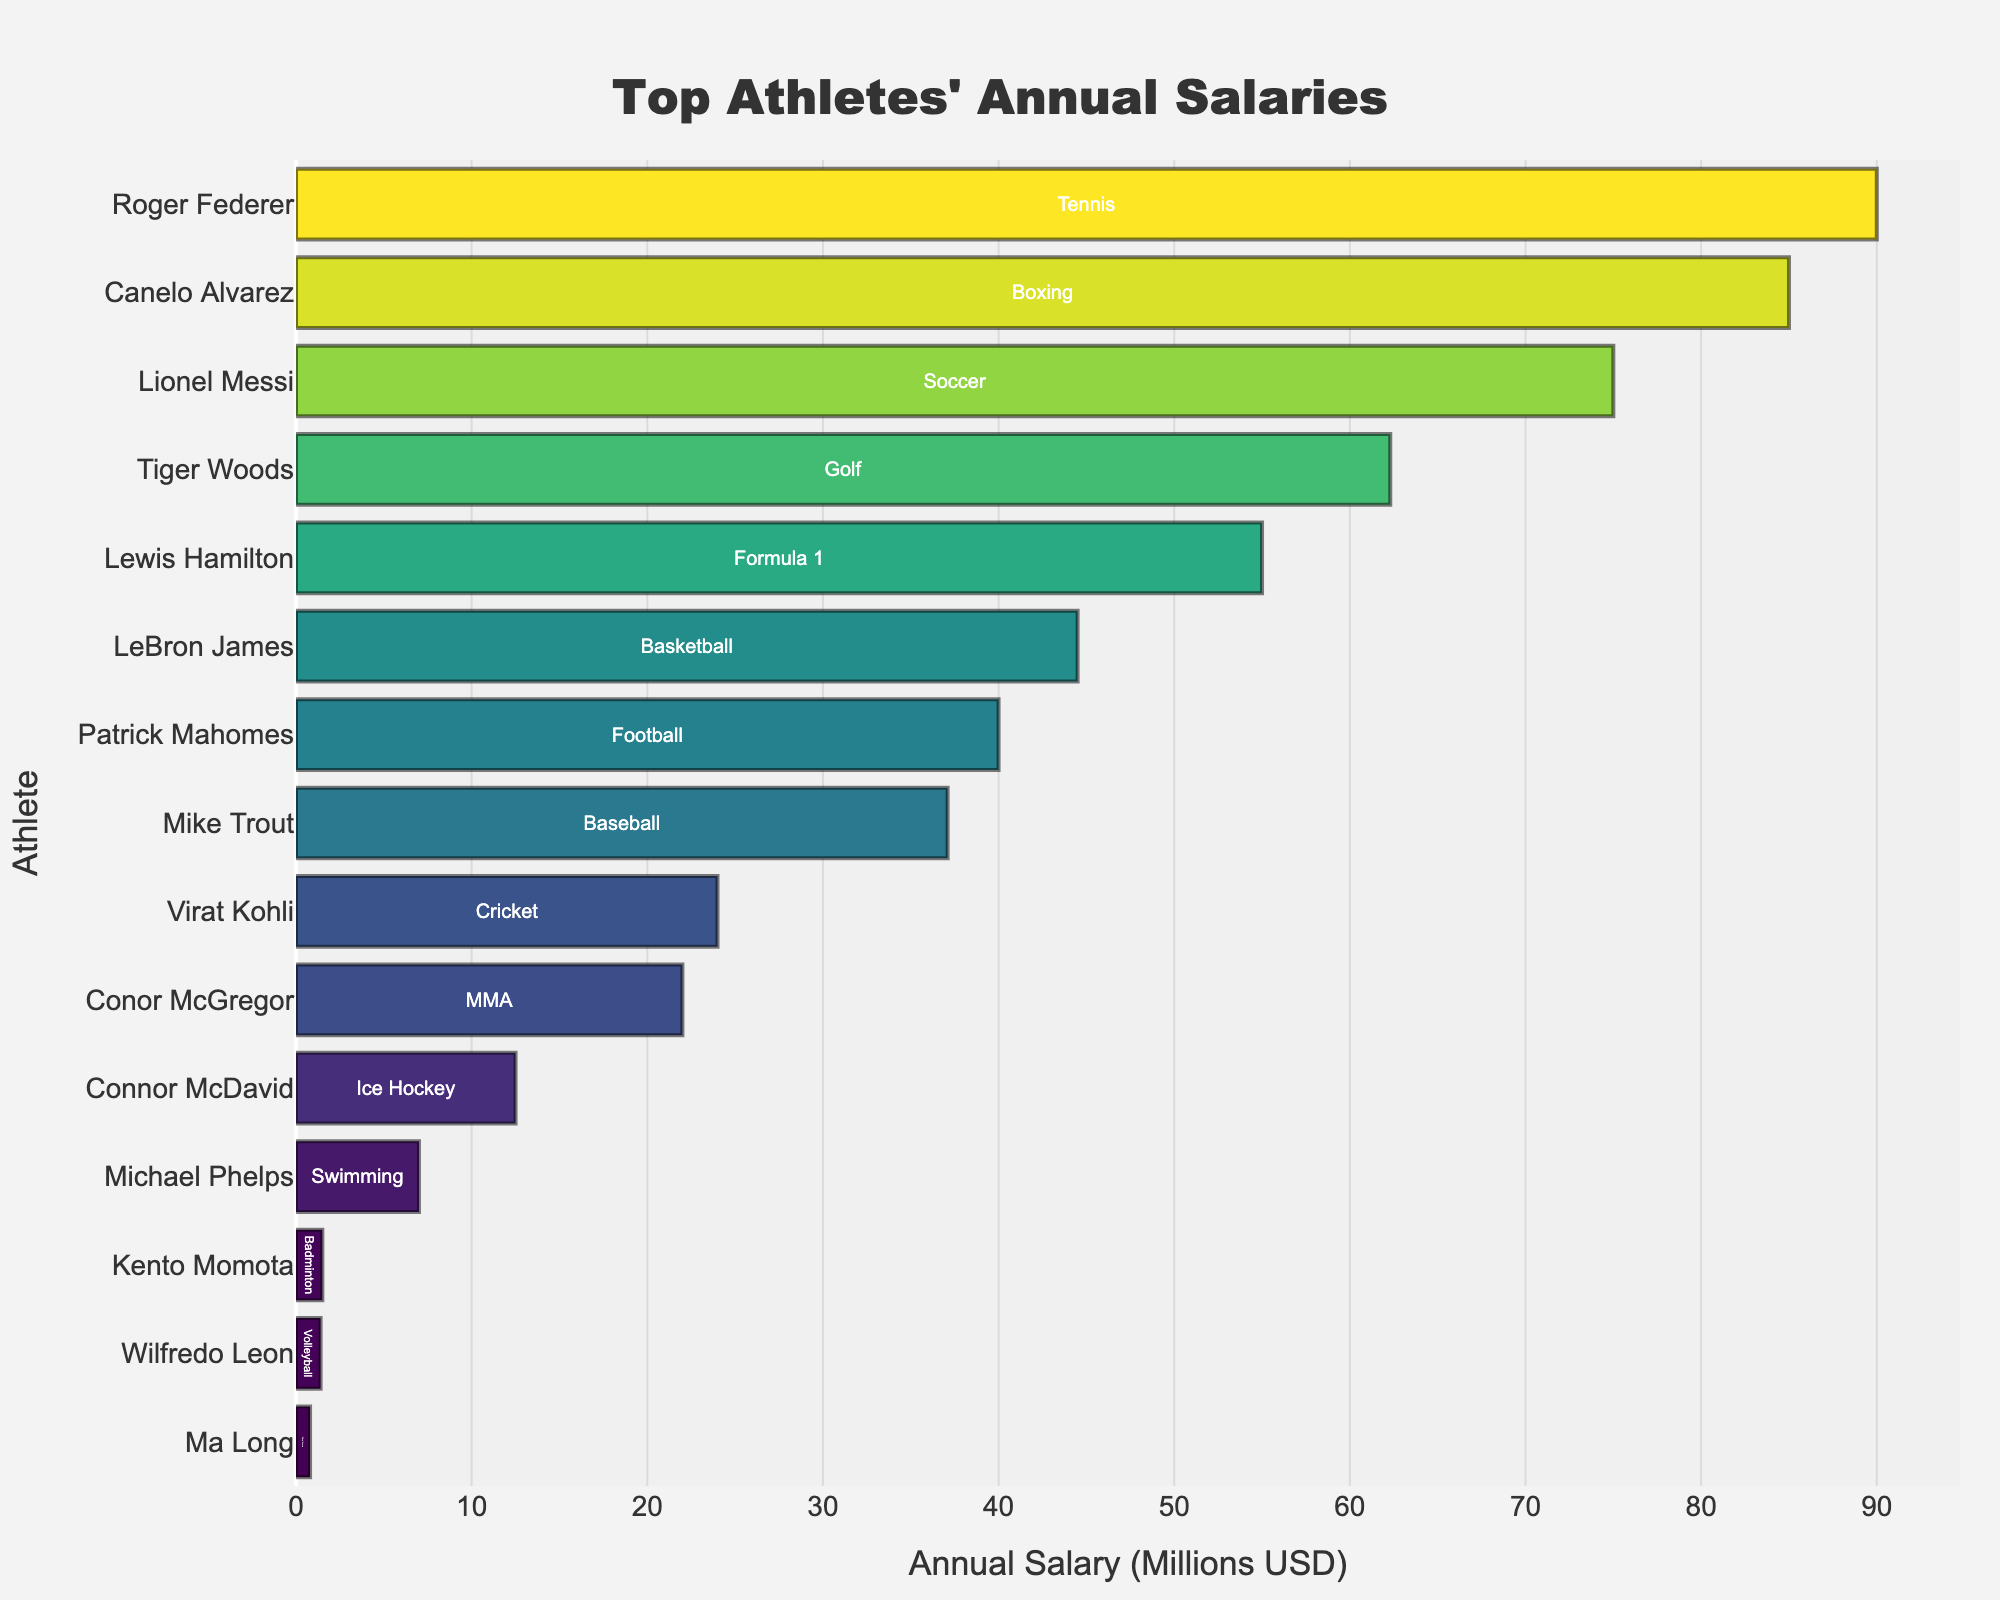Which athlete has the highest annual salary? The bar chart shows the annual salaries of athletes in descending order. The longest bar at the top represents Roger Federer with the highest salary.
Answer: Roger Federer Who has a higher annual salary, LeBron James or Patrick Mahomes? The bar representing LeBron James is longer than the bar representing Patrick Mahomes, indicating a higher salary.
Answer: LeBron James What's the combined annual salary of the top three highest-paid athletes? The top three athletes by salary are Roger Federer (90.0), Canelo Alvarez (85.0), and Lionel Messi (75.0). Their combined salary is 90.0 + 85.0 + 75.0 = 250.0 million USD.
Answer: 250.0 million USD Which sport has the highest-paid athlete, and what is their salary? Tennis has Roger Federer, the highest-paid athlete, with a salary of 90.0 million USD, as indicated by the tallest bar.
Answer: Tennis, 90.0 million USD How many athletes have an annual salary greater than 50 million USD? Roger Federer, Canelo Alvarez, Lionel Messi, and Lewis Hamilton each have bars representing salaries greater than 50 million USD. Therefore, there are 4 athletes.
Answer: 4 athletes What is the salary difference between the highest-paid and the lowest-paid athlete? The highest-paid athlete, Roger Federer, has a salary of 90.0 million USD, and the lowest-paid athlete, Ma Long, has a salary of 0.8 million USD. The difference is 90.0 - 0.8 = 89.2 million USD.
Answer: 89.2 million USD What is the average annual salary of the athletes representing Basketball and Football? LeBron James (Basketball) has a salary of 44.5 million USD, and Patrick Mahomes (Football) has a salary of 40.0 million USD. The average salary is (44.5 + 40.0) / 2 = 42.25 million USD.
Answer: 42.25 million USD Which athlete representing new or less famous sports earns the lowest among them, and what is their salary? The athletes representing lesser-known sports are Wilfredo Leon (Volleyball), Ma Long (Table Tennis), and Kento Momota (Badminton). Ma Long has the shortest bar indicating the lowest salary of 0.8 million USD.
Answer: Ma Long, 0.8 million USD What is the total annual salary for athletes in team sports (Basketball, Football, Soccer, Baseball, Cricket, Ice Hockey)? The salaries for team sports athletes are LeBron James (44.5), Patrick Mahomes (40.0), Lionel Messi (75.0), Mike Trout (37.1), Virat Kohli (24.0), Connor McDavid (12.5). Their total is 44.5 + 40.0 + 75.0 + 37.1 + 24.0 + 12.5 = 233.1 million USD.
Answer: 233.1 million USD Who earns more from endorsements than their salary, assuming some players have known endorsement deals? While the chart doesn't provide endorsement information, Roger Federer is widely known for significant endorsement earnings exceeding his salary.
Answer: Roger Federer 